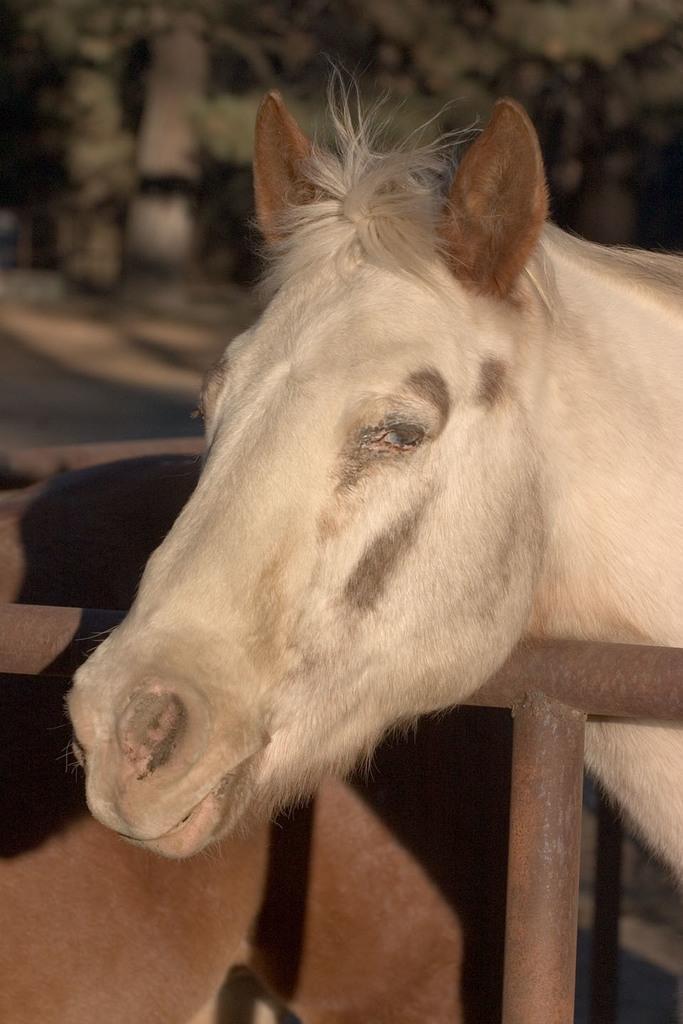Can you describe this image briefly? In this image we can see face of a horse which is white in color standing behind the fencing and the background image is blur. 